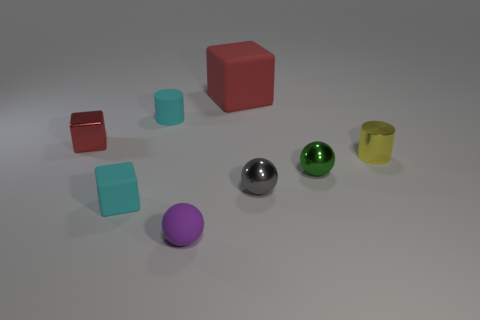Add 1 small cyan rubber objects. How many objects exist? 9 Subtract all big red cubes. How many cubes are left? 2 Subtract all balls. How many objects are left? 5 Subtract 3 blocks. How many blocks are left? 0 Subtract all red cylinders. How many red cubes are left? 2 Subtract all small brown balls. Subtract all cyan rubber blocks. How many objects are left? 7 Add 8 shiny spheres. How many shiny spheres are left? 10 Add 3 brown metal cylinders. How many brown metal cylinders exist? 3 Subtract all red blocks. How many blocks are left? 1 Subtract 0 purple cylinders. How many objects are left? 8 